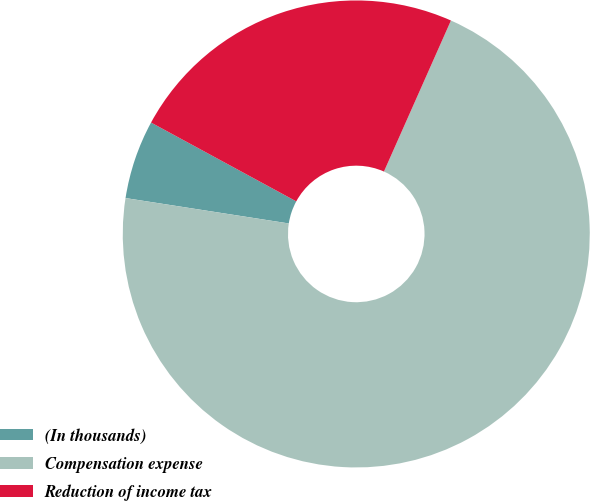Convert chart. <chart><loc_0><loc_0><loc_500><loc_500><pie_chart><fcel>(In thousands)<fcel>Compensation expense<fcel>Reduction of income tax<nl><fcel>5.46%<fcel>70.81%<fcel>23.73%<nl></chart> 